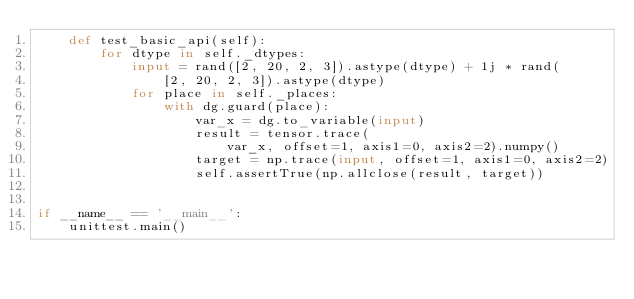Convert code to text. <code><loc_0><loc_0><loc_500><loc_500><_Python_>    def test_basic_api(self):
        for dtype in self._dtypes:
            input = rand([2, 20, 2, 3]).astype(dtype) + 1j * rand(
                [2, 20, 2, 3]).astype(dtype)
            for place in self._places:
                with dg.guard(place):
                    var_x = dg.to_variable(input)
                    result = tensor.trace(
                        var_x, offset=1, axis1=0, axis2=2).numpy()
                    target = np.trace(input, offset=1, axis1=0, axis2=2)
                    self.assertTrue(np.allclose(result, target))


if __name__ == '__main__':
    unittest.main()
</code> 